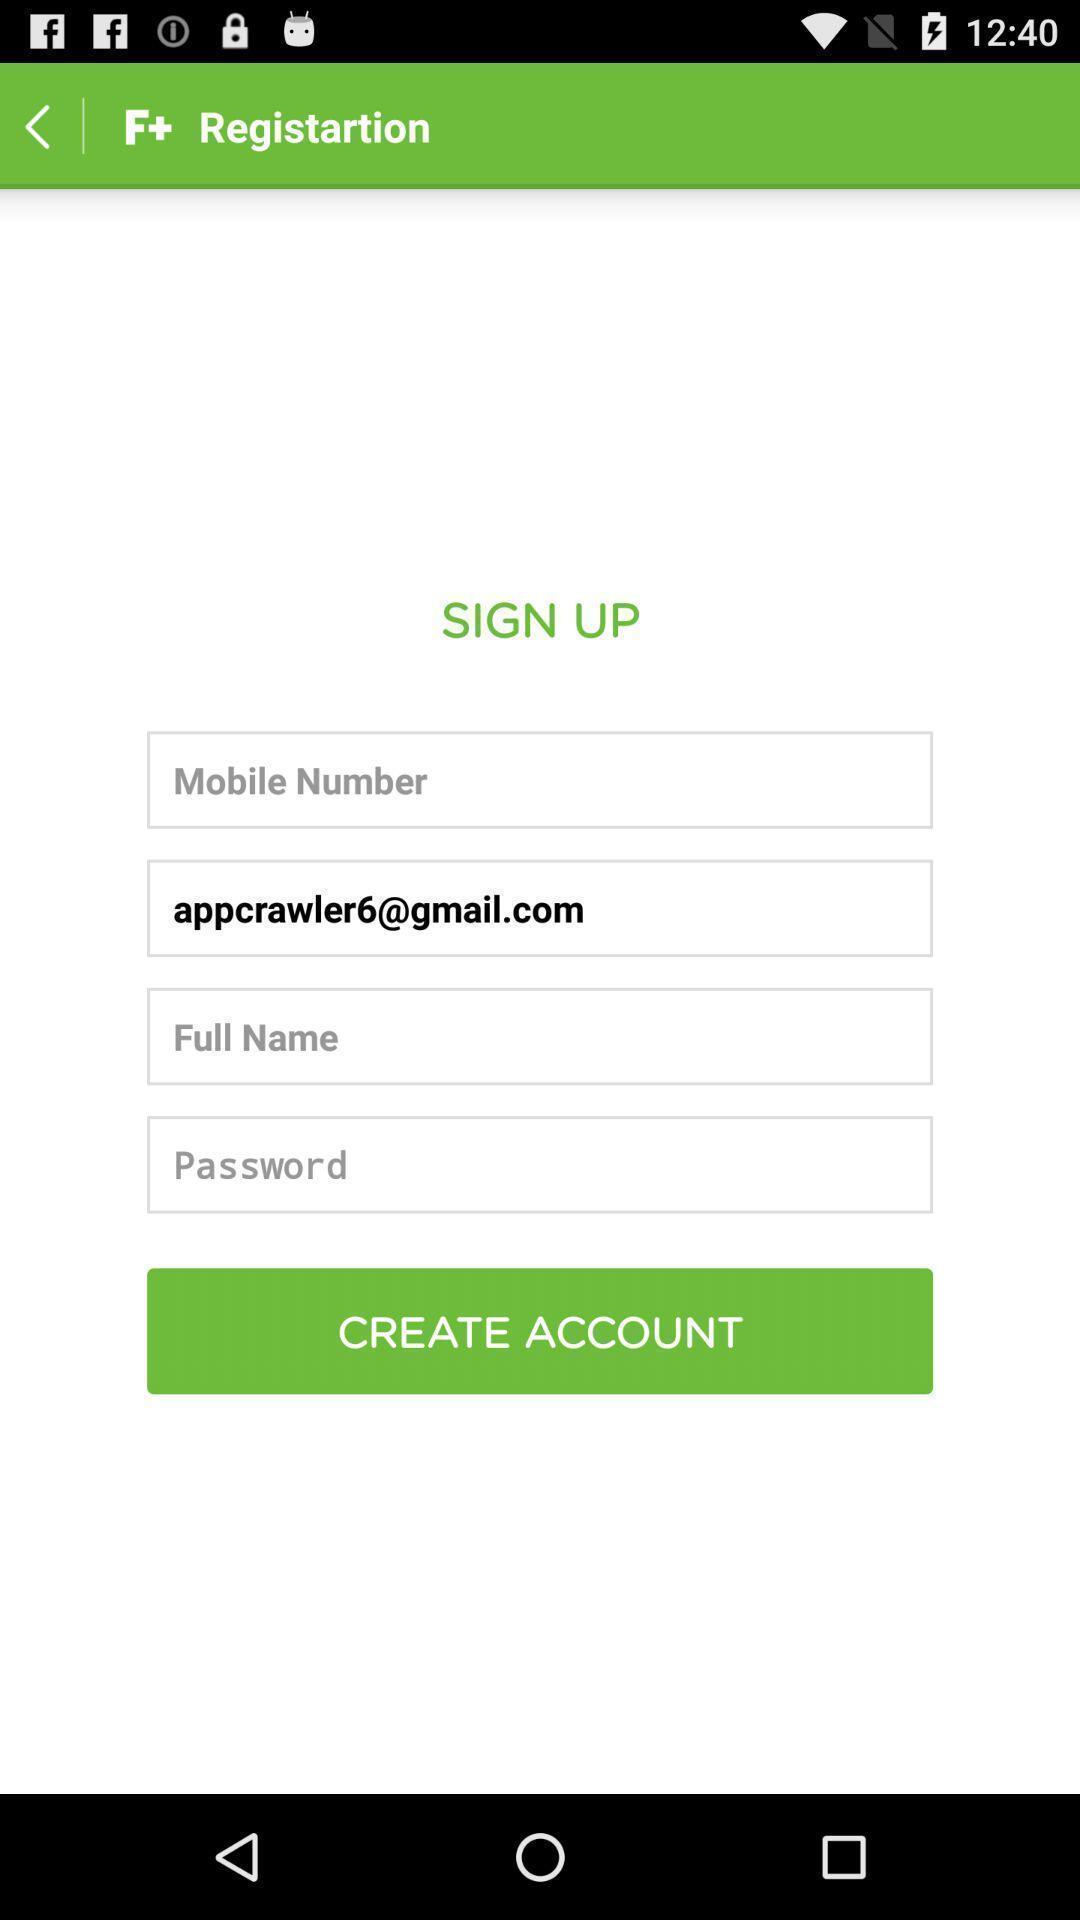Summarize the information in this screenshot. Sign up page. 